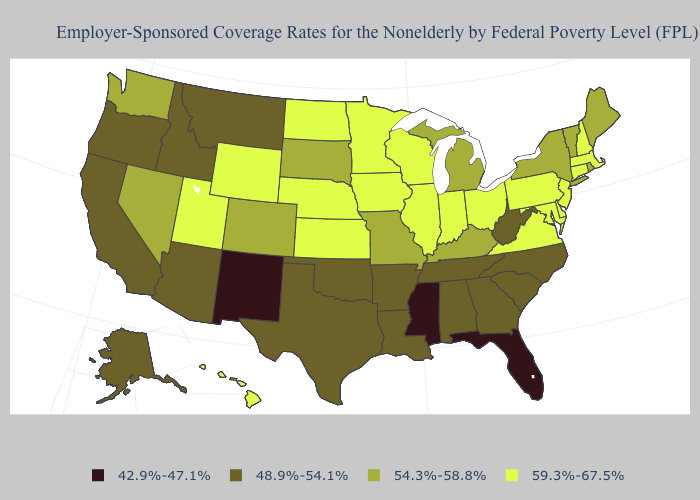Among the states that border Michigan , which have the highest value?
Keep it brief. Indiana, Ohio, Wisconsin. What is the lowest value in the USA?
Concise answer only. 42.9%-47.1%. Which states have the lowest value in the West?
Short answer required. New Mexico. Which states hav the highest value in the Northeast?
Concise answer only. Connecticut, Massachusetts, New Hampshire, New Jersey, Pennsylvania. What is the value of Oklahoma?
Give a very brief answer. 48.9%-54.1%. Does New Hampshire have the same value as Texas?
Concise answer only. No. Among the states that border New Mexico , does Utah have the highest value?
Concise answer only. Yes. What is the highest value in the West ?
Be succinct. 59.3%-67.5%. What is the value of Nebraska?
Short answer required. 59.3%-67.5%. Name the states that have a value in the range 48.9%-54.1%?
Quick response, please. Alabama, Alaska, Arizona, Arkansas, California, Georgia, Idaho, Louisiana, Montana, North Carolina, Oklahoma, Oregon, South Carolina, Tennessee, Texas, West Virginia. What is the lowest value in states that border Illinois?
Short answer required. 54.3%-58.8%. Which states have the lowest value in the West?
Keep it brief. New Mexico. Does the map have missing data?
Quick response, please. No. What is the lowest value in the West?
Write a very short answer. 42.9%-47.1%. Does Louisiana have a lower value than North Carolina?
Keep it brief. No. 